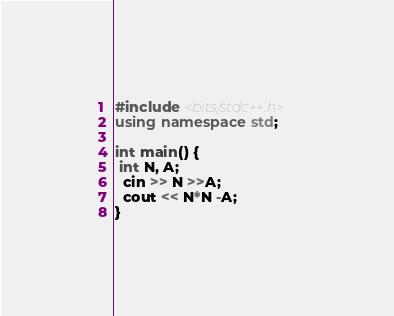<code> <loc_0><loc_0><loc_500><loc_500><_C++_>#include <bits/stdc++.h>
using namespace std;

int main() {
 int N, A;
  cin >> N >>A;
  cout << N*N -A;
}
</code> 